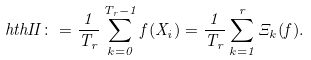Convert formula to latex. <formula><loc_0><loc_0><loc_500><loc_500>\ h t h I I \colon = \frac { 1 } { T _ { r } } \sum _ { k = 0 } ^ { T _ { r } - 1 } f ( X _ { i } ) = \frac { 1 } { T _ { r } } \sum _ { k = 1 } ^ { r } \Xi _ { k } ( f ) .</formula> 